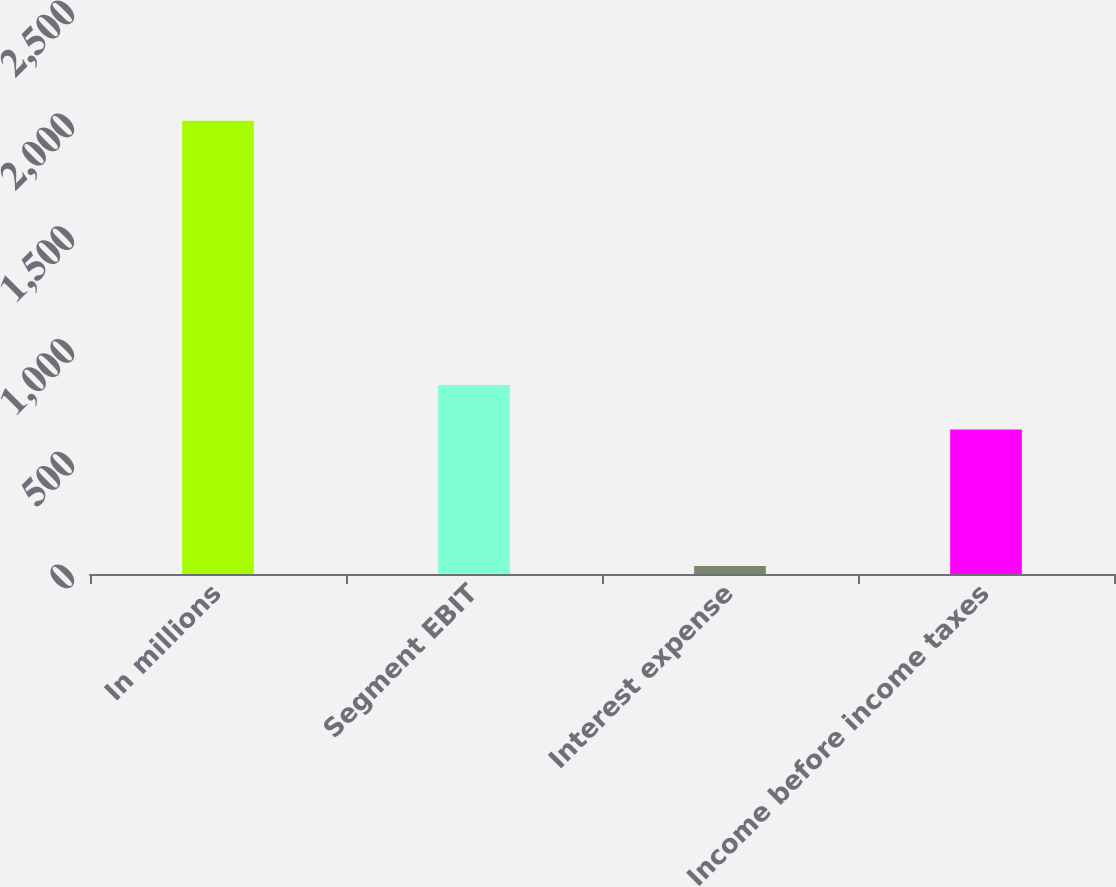<chart> <loc_0><loc_0><loc_500><loc_500><bar_chart><fcel>In millions<fcel>Segment EBIT<fcel>Interest expense<fcel>Income before income taxes<nl><fcel>2009<fcel>837.4<fcel>35<fcel>640<nl></chart> 